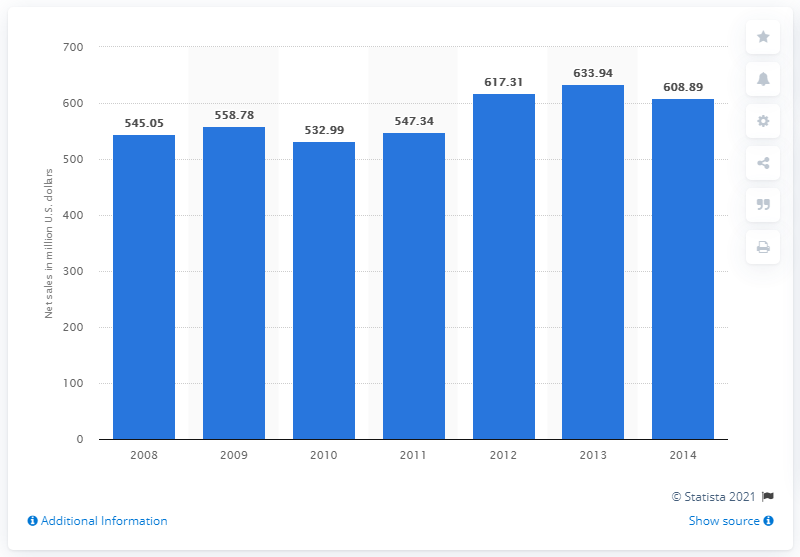Indicate a few pertinent items in this graphic. In 2011, the global net sales of American Apparel were 547.34 million dollars. 